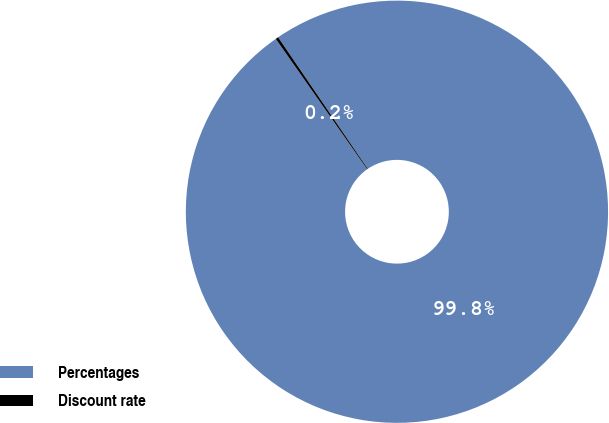Convert chart. <chart><loc_0><loc_0><loc_500><loc_500><pie_chart><fcel>Percentages<fcel>Discount rate<nl><fcel>99.79%<fcel>0.21%<nl></chart> 